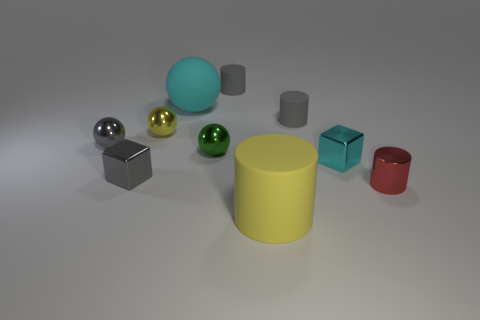What is the shape of the small object that is the same color as the big rubber cylinder?
Provide a short and direct response. Sphere. How many small gray objects are there?
Keep it short and to the point. 4. Do the yellow ball that is behind the small green metallic ball and the tiny block that is on the right side of the green metallic sphere have the same material?
Make the answer very short. Yes. There is a yellow object that is the same material as the gray block; what size is it?
Provide a succinct answer. Small. The large object in front of the tiny cyan cube has what shape?
Keep it short and to the point. Cylinder. There is a big thing to the left of the small green metal sphere; does it have the same color as the tiny matte thing right of the large yellow cylinder?
Provide a short and direct response. No. What is the size of the thing that is the same color as the big ball?
Your response must be concise. Small. Are there any green spheres?
Your response must be concise. Yes. There is a big rubber thing in front of the gray shiny sphere behind the tiny metal sphere to the right of the cyan rubber sphere; what shape is it?
Your response must be concise. Cylinder. What number of small cyan metallic cubes are behind the small red thing?
Provide a short and direct response. 1. 